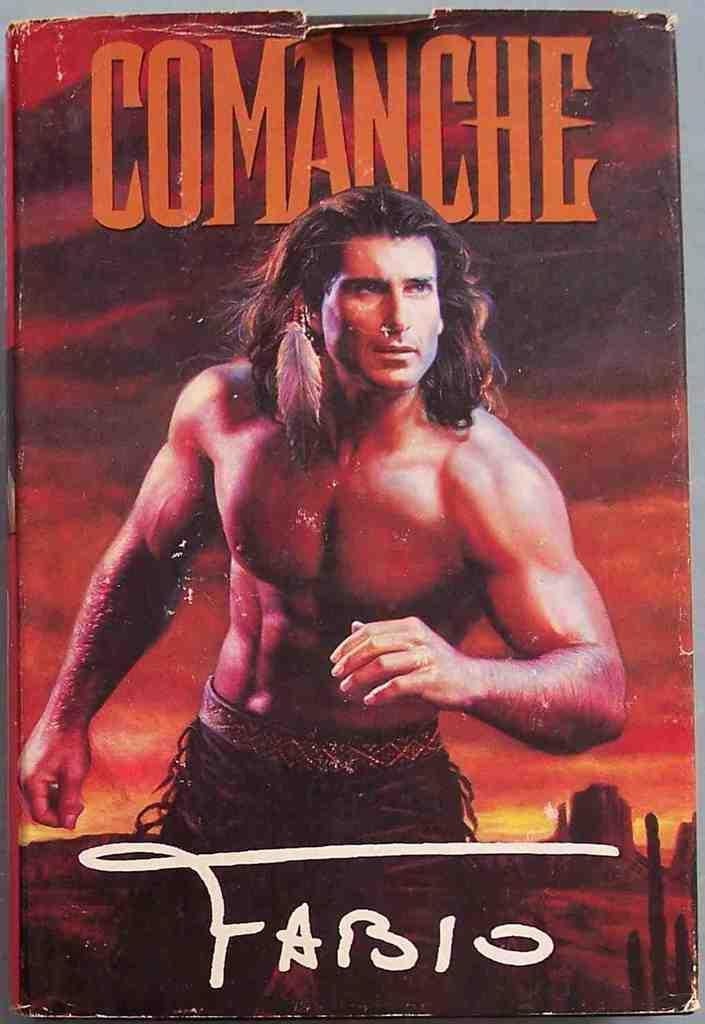Could you give a brief overview of what you see in this image? As we can see in the image there is a poster. On poster there is a man, buildings, sky, clouds and something written. 